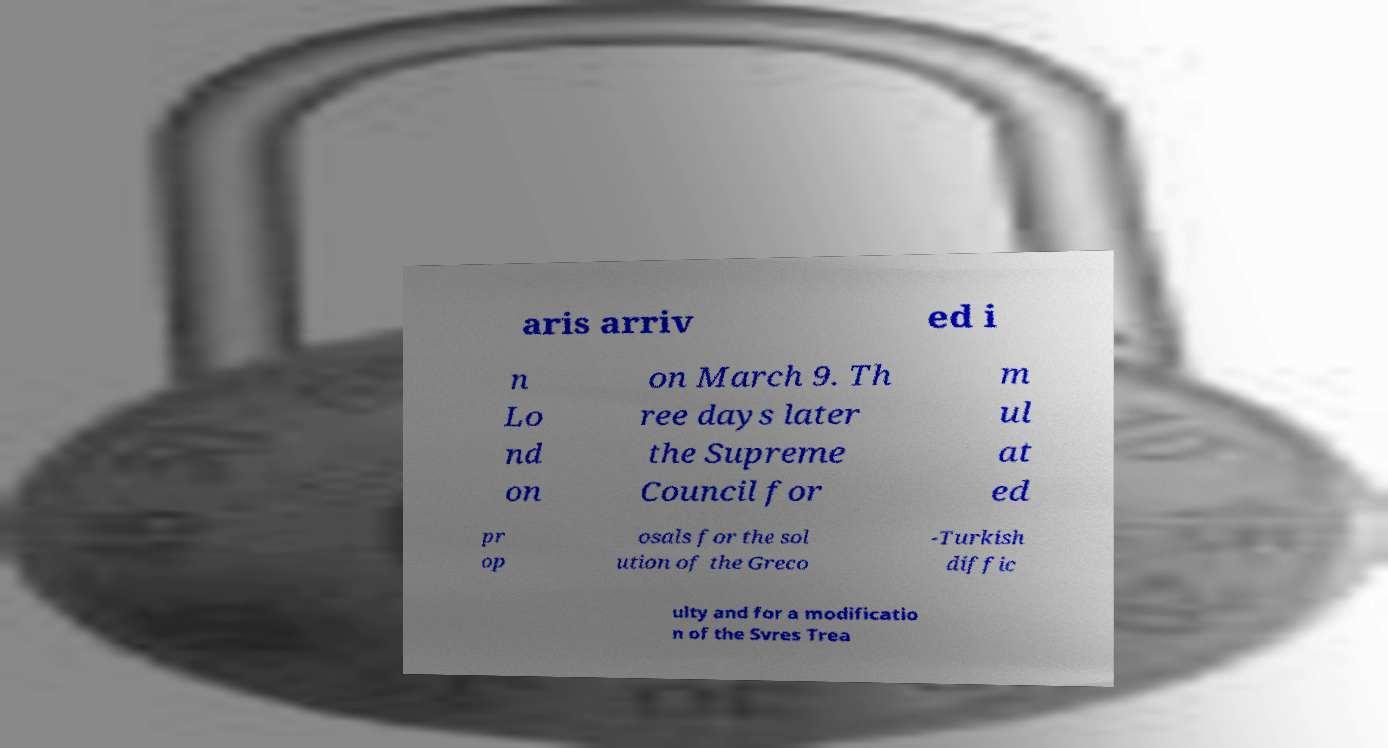Please identify and transcribe the text found in this image. aris arriv ed i n Lo nd on on March 9. Th ree days later the Supreme Council for m ul at ed pr op osals for the sol ution of the Greco -Turkish diffic ulty and for a modificatio n of the Svres Trea 